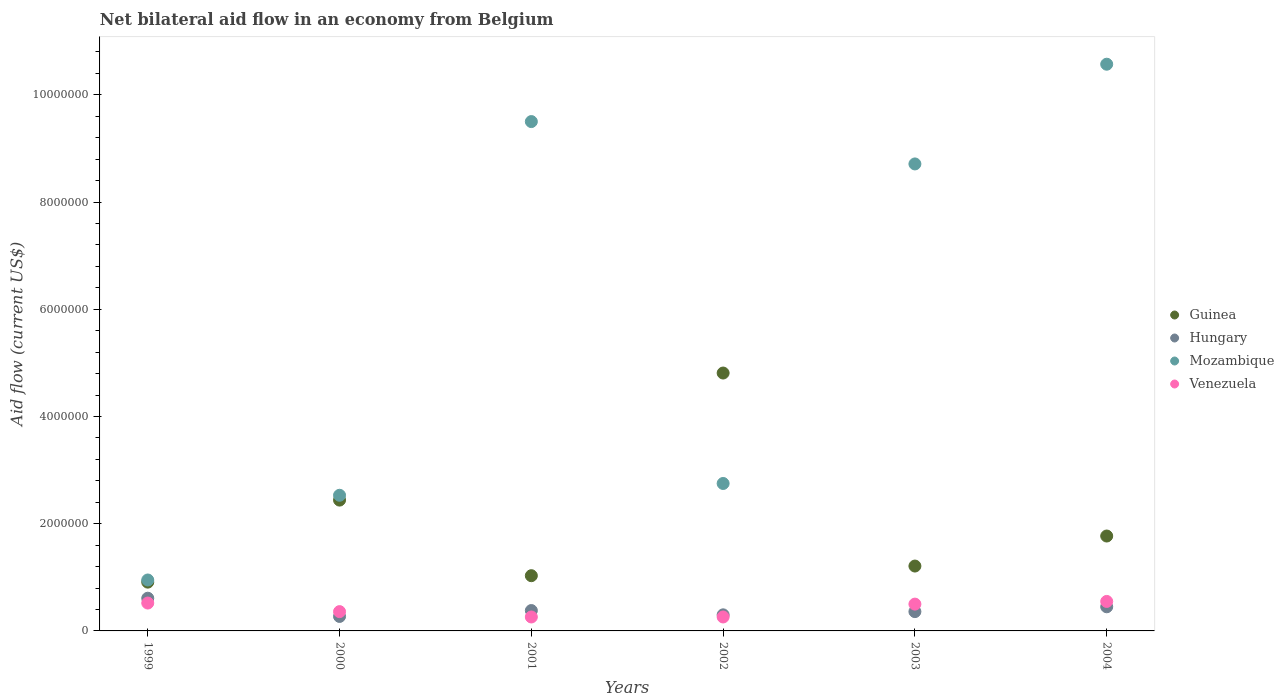How many different coloured dotlines are there?
Provide a short and direct response. 4. Is the number of dotlines equal to the number of legend labels?
Give a very brief answer. Yes. What is the net bilateral aid flow in Venezuela in 1999?
Keep it short and to the point. 5.20e+05. Across all years, what is the maximum net bilateral aid flow in Hungary?
Offer a very short reply. 6.10e+05. Across all years, what is the minimum net bilateral aid flow in Guinea?
Keep it short and to the point. 9.10e+05. What is the total net bilateral aid flow in Guinea in the graph?
Ensure brevity in your answer.  1.22e+07. What is the difference between the net bilateral aid flow in Hungary in 2004 and the net bilateral aid flow in Guinea in 2000?
Ensure brevity in your answer.  -1.99e+06. What is the average net bilateral aid flow in Guinea per year?
Your response must be concise. 2.03e+06. In the year 2001, what is the difference between the net bilateral aid flow in Venezuela and net bilateral aid flow in Hungary?
Your response must be concise. -1.20e+05. In how many years, is the net bilateral aid flow in Venezuela greater than 7600000 US$?
Provide a succinct answer. 0. What is the ratio of the net bilateral aid flow in Hungary in 2000 to that in 2003?
Provide a succinct answer. 0.75. What is the difference between the highest and the lowest net bilateral aid flow in Venezuela?
Give a very brief answer. 2.90e+05. Is it the case that in every year, the sum of the net bilateral aid flow in Hungary and net bilateral aid flow in Guinea  is greater than the sum of net bilateral aid flow in Venezuela and net bilateral aid flow in Mozambique?
Ensure brevity in your answer.  Yes. Is the net bilateral aid flow in Venezuela strictly greater than the net bilateral aid flow in Hungary over the years?
Give a very brief answer. No. How many dotlines are there?
Keep it short and to the point. 4. Are the values on the major ticks of Y-axis written in scientific E-notation?
Your answer should be very brief. No. Does the graph contain any zero values?
Offer a terse response. No. Does the graph contain grids?
Your answer should be very brief. No. How are the legend labels stacked?
Keep it short and to the point. Vertical. What is the title of the graph?
Provide a short and direct response. Net bilateral aid flow in an economy from Belgium. What is the label or title of the X-axis?
Give a very brief answer. Years. What is the label or title of the Y-axis?
Keep it short and to the point. Aid flow (current US$). What is the Aid flow (current US$) in Guinea in 1999?
Keep it short and to the point. 9.10e+05. What is the Aid flow (current US$) of Hungary in 1999?
Provide a short and direct response. 6.10e+05. What is the Aid flow (current US$) of Mozambique in 1999?
Ensure brevity in your answer.  9.50e+05. What is the Aid flow (current US$) of Venezuela in 1999?
Keep it short and to the point. 5.20e+05. What is the Aid flow (current US$) in Guinea in 2000?
Your answer should be very brief. 2.44e+06. What is the Aid flow (current US$) in Mozambique in 2000?
Give a very brief answer. 2.53e+06. What is the Aid flow (current US$) in Venezuela in 2000?
Offer a very short reply. 3.60e+05. What is the Aid flow (current US$) in Guinea in 2001?
Your response must be concise. 1.03e+06. What is the Aid flow (current US$) of Hungary in 2001?
Provide a succinct answer. 3.80e+05. What is the Aid flow (current US$) of Mozambique in 2001?
Provide a short and direct response. 9.50e+06. What is the Aid flow (current US$) of Venezuela in 2001?
Ensure brevity in your answer.  2.60e+05. What is the Aid flow (current US$) in Guinea in 2002?
Provide a succinct answer. 4.81e+06. What is the Aid flow (current US$) in Hungary in 2002?
Your response must be concise. 3.00e+05. What is the Aid flow (current US$) of Mozambique in 2002?
Your answer should be compact. 2.75e+06. What is the Aid flow (current US$) of Guinea in 2003?
Keep it short and to the point. 1.21e+06. What is the Aid flow (current US$) of Mozambique in 2003?
Give a very brief answer. 8.71e+06. What is the Aid flow (current US$) of Guinea in 2004?
Offer a terse response. 1.77e+06. What is the Aid flow (current US$) in Mozambique in 2004?
Give a very brief answer. 1.06e+07. What is the Aid flow (current US$) in Venezuela in 2004?
Offer a very short reply. 5.50e+05. Across all years, what is the maximum Aid flow (current US$) in Guinea?
Provide a succinct answer. 4.81e+06. Across all years, what is the maximum Aid flow (current US$) of Hungary?
Your response must be concise. 6.10e+05. Across all years, what is the maximum Aid flow (current US$) in Mozambique?
Keep it short and to the point. 1.06e+07. Across all years, what is the maximum Aid flow (current US$) in Venezuela?
Make the answer very short. 5.50e+05. Across all years, what is the minimum Aid flow (current US$) of Guinea?
Provide a succinct answer. 9.10e+05. Across all years, what is the minimum Aid flow (current US$) of Hungary?
Provide a succinct answer. 2.70e+05. Across all years, what is the minimum Aid flow (current US$) of Mozambique?
Keep it short and to the point. 9.50e+05. Across all years, what is the minimum Aid flow (current US$) in Venezuela?
Your response must be concise. 2.60e+05. What is the total Aid flow (current US$) in Guinea in the graph?
Make the answer very short. 1.22e+07. What is the total Aid flow (current US$) in Hungary in the graph?
Ensure brevity in your answer.  2.37e+06. What is the total Aid flow (current US$) of Mozambique in the graph?
Your answer should be compact. 3.50e+07. What is the total Aid flow (current US$) of Venezuela in the graph?
Provide a succinct answer. 2.45e+06. What is the difference between the Aid flow (current US$) in Guinea in 1999 and that in 2000?
Make the answer very short. -1.53e+06. What is the difference between the Aid flow (current US$) in Mozambique in 1999 and that in 2000?
Offer a terse response. -1.58e+06. What is the difference between the Aid flow (current US$) of Venezuela in 1999 and that in 2000?
Make the answer very short. 1.60e+05. What is the difference between the Aid flow (current US$) of Hungary in 1999 and that in 2001?
Provide a succinct answer. 2.30e+05. What is the difference between the Aid flow (current US$) in Mozambique in 1999 and that in 2001?
Your answer should be compact. -8.55e+06. What is the difference between the Aid flow (current US$) in Guinea in 1999 and that in 2002?
Offer a very short reply. -3.90e+06. What is the difference between the Aid flow (current US$) of Hungary in 1999 and that in 2002?
Ensure brevity in your answer.  3.10e+05. What is the difference between the Aid flow (current US$) in Mozambique in 1999 and that in 2002?
Provide a succinct answer. -1.80e+06. What is the difference between the Aid flow (current US$) of Venezuela in 1999 and that in 2002?
Your answer should be very brief. 2.60e+05. What is the difference between the Aid flow (current US$) of Guinea in 1999 and that in 2003?
Make the answer very short. -3.00e+05. What is the difference between the Aid flow (current US$) of Hungary in 1999 and that in 2003?
Offer a very short reply. 2.50e+05. What is the difference between the Aid flow (current US$) in Mozambique in 1999 and that in 2003?
Keep it short and to the point. -7.76e+06. What is the difference between the Aid flow (current US$) of Guinea in 1999 and that in 2004?
Keep it short and to the point. -8.60e+05. What is the difference between the Aid flow (current US$) of Mozambique in 1999 and that in 2004?
Give a very brief answer. -9.62e+06. What is the difference between the Aid flow (current US$) in Venezuela in 1999 and that in 2004?
Offer a terse response. -3.00e+04. What is the difference between the Aid flow (current US$) of Guinea in 2000 and that in 2001?
Your answer should be very brief. 1.41e+06. What is the difference between the Aid flow (current US$) of Mozambique in 2000 and that in 2001?
Offer a terse response. -6.97e+06. What is the difference between the Aid flow (current US$) in Venezuela in 2000 and that in 2001?
Provide a short and direct response. 1.00e+05. What is the difference between the Aid flow (current US$) of Guinea in 2000 and that in 2002?
Provide a succinct answer. -2.37e+06. What is the difference between the Aid flow (current US$) of Hungary in 2000 and that in 2002?
Provide a succinct answer. -3.00e+04. What is the difference between the Aid flow (current US$) of Mozambique in 2000 and that in 2002?
Provide a succinct answer. -2.20e+05. What is the difference between the Aid flow (current US$) in Venezuela in 2000 and that in 2002?
Ensure brevity in your answer.  1.00e+05. What is the difference between the Aid flow (current US$) of Guinea in 2000 and that in 2003?
Your answer should be very brief. 1.23e+06. What is the difference between the Aid flow (current US$) in Mozambique in 2000 and that in 2003?
Provide a succinct answer. -6.18e+06. What is the difference between the Aid flow (current US$) of Venezuela in 2000 and that in 2003?
Ensure brevity in your answer.  -1.40e+05. What is the difference between the Aid flow (current US$) in Guinea in 2000 and that in 2004?
Make the answer very short. 6.70e+05. What is the difference between the Aid flow (current US$) of Hungary in 2000 and that in 2004?
Provide a short and direct response. -1.80e+05. What is the difference between the Aid flow (current US$) in Mozambique in 2000 and that in 2004?
Ensure brevity in your answer.  -8.04e+06. What is the difference between the Aid flow (current US$) of Venezuela in 2000 and that in 2004?
Ensure brevity in your answer.  -1.90e+05. What is the difference between the Aid flow (current US$) of Guinea in 2001 and that in 2002?
Give a very brief answer. -3.78e+06. What is the difference between the Aid flow (current US$) in Mozambique in 2001 and that in 2002?
Offer a very short reply. 6.75e+06. What is the difference between the Aid flow (current US$) of Venezuela in 2001 and that in 2002?
Provide a succinct answer. 0. What is the difference between the Aid flow (current US$) in Guinea in 2001 and that in 2003?
Your answer should be compact. -1.80e+05. What is the difference between the Aid flow (current US$) in Mozambique in 2001 and that in 2003?
Provide a succinct answer. 7.90e+05. What is the difference between the Aid flow (current US$) of Venezuela in 2001 and that in 2003?
Your answer should be very brief. -2.40e+05. What is the difference between the Aid flow (current US$) of Guinea in 2001 and that in 2004?
Offer a very short reply. -7.40e+05. What is the difference between the Aid flow (current US$) in Mozambique in 2001 and that in 2004?
Your response must be concise. -1.07e+06. What is the difference between the Aid flow (current US$) of Guinea in 2002 and that in 2003?
Provide a succinct answer. 3.60e+06. What is the difference between the Aid flow (current US$) of Hungary in 2002 and that in 2003?
Make the answer very short. -6.00e+04. What is the difference between the Aid flow (current US$) of Mozambique in 2002 and that in 2003?
Your answer should be very brief. -5.96e+06. What is the difference between the Aid flow (current US$) of Guinea in 2002 and that in 2004?
Offer a terse response. 3.04e+06. What is the difference between the Aid flow (current US$) in Mozambique in 2002 and that in 2004?
Ensure brevity in your answer.  -7.82e+06. What is the difference between the Aid flow (current US$) in Guinea in 2003 and that in 2004?
Offer a very short reply. -5.60e+05. What is the difference between the Aid flow (current US$) of Mozambique in 2003 and that in 2004?
Offer a very short reply. -1.86e+06. What is the difference between the Aid flow (current US$) of Guinea in 1999 and the Aid flow (current US$) of Hungary in 2000?
Give a very brief answer. 6.40e+05. What is the difference between the Aid flow (current US$) in Guinea in 1999 and the Aid flow (current US$) in Mozambique in 2000?
Offer a terse response. -1.62e+06. What is the difference between the Aid flow (current US$) of Hungary in 1999 and the Aid flow (current US$) of Mozambique in 2000?
Keep it short and to the point. -1.92e+06. What is the difference between the Aid flow (current US$) of Hungary in 1999 and the Aid flow (current US$) of Venezuela in 2000?
Give a very brief answer. 2.50e+05. What is the difference between the Aid flow (current US$) of Mozambique in 1999 and the Aid flow (current US$) of Venezuela in 2000?
Give a very brief answer. 5.90e+05. What is the difference between the Aid flow (current US$) in Guinea in 1999 and the Aid flow (current US$) in Hungary in 2001?
Keep it short and to the point. 5.30e+05. What is the difference between the Aid flow (current US$) in Guinea in 1999 and the Aid flow (current US$) in Mozambique in 2001?
Your answer should be compact. -8.59e+06. What is the difference between the Aid flow (current US$) of Guinea in 1999 and the Aid flow (current US$) of Venezuela in 2001?
Offer a very short reply. 6.50e+05. What is the difference between the Aid flow (current US$) in Hungary in 1999 and the Aid flow (current US$) in Mozambique in 2001?
Your response must be concise. -8.89e+06. What is the difference between the Aid flow (current US$) in Mozambique in 1999 and the Aid flow (current US$) in Venezuela in 2001?
Your response must be concise. 6.90e+05. What is the difference between the Aid flow (current US$) of Guinea in 1999 and the Aid flow (current US$) of Mozambique in 2002?
Keep it short and to the point. -1.84e+06. What is the difference between the Aid flow (current US$) in Guinea in 1999 and the Aid flow (current US$) in Venezuela in 2002?
Your answer should be very brief. 6.50e+05. What is the difference between the Aid flow (current US$) in Hungary in 1999 and the Aid flow (current US$) in Mozambique in 2002?
Give a very brief answer. -2.14e+06. What is the difference between the Aid flow (current US$) in Mozambique in 1999 and the Aid flow (current US$) in Venezuela in 2002?
Provide a short and direct response. 6.90e+05. What is the difference between the Aid flow (current US$) of Guinea in 1999 and the Aid flow (current US$) of Hungary in 2003?
Your answer should be very brief. 5.50e+05. What is the difference between the Aid flow (current US$) of Guinea in 1999 and the Aid flow (current US$) of Mozambique in 2003?
Give a very brief answer. -7.80e+06. What is the difference between the Aid flow (current US$) in Hungary in 1999 and the Aid flow (current US$) in Mozambique in 2003?
Offer a terse response. -8.10e+06. What is the difference between the Aid flow (current US$) in Hungary in 1999 and the Aid flow (current US$) in Venezuela in 2003?
Make the answer very short. 1.10e+05. What is the difference between the Aid flow (current US$) in Mozambique in 1999 and the Aid flow (current US$) in Venezuela in 2003?
Give a very brief answer. 4.50e+05. What is the difference between the Aid flow (current US$) of Guinea in 1999 and the Aid flow (current US$) of Hungary in 2004?
Provide a succinct answer. 4.60e+05. What is the difference between the Aid flow (current US$) in Guinea in 1999 and the Aid flow (current US$) in Mozambique in 2004?
Offer a terse response. -9.66e+06. What is the difference between the Aid flow (current US$) in Guinea in 1999 and the Aid flow (current US$) in Venezuela in 2004?
Keep it short and to the point. 3.60e+05. What is the difference between the Aid flow (current US$) in Hungary in 1999 and the Aid flow (current US$) in Mozambique in 2004?
Give a very brief answer. -9.96e+06. What is the difference between the Aid flow (current US$) of Hungary in 1999 and the Aid flow (current US$) of Venezuela in 2004?
Give a very brief answer. 6.00e+04. What is the difference between the Aid flow (current US$) in Guinea in 2000 and the Aid flow (current US$) in Hungary in 2001?
Keep it short and to the point. 2.06e+06. What is the difference between the Aid flow (current US$) in Guinea in 2000 and the Aid flow (current US$) in Mozambique in 2001?
Your answer should be compact. -7.06e+06. What is the difference between the Aid flow (current US$) of Guinea in 2000 and the Aid flow (current US$) of Venezuela in 2001?
Provide a short and direct response. 2.18e+06. What is the difference between the Aid flow (current US$) of Hungary in 2000 and the Aid flow (current US$) of Mozambique in 2001?
Your answer should be very brief. -9.23e+06. What is the difference between the Aid flow (current US$) in Mozambique in 2000 and the Aid flow (current US$) in Venezuela in 2001?
Your response must be concise. 2.27e+06. What is the difference between the Aid flow (current US$) in Guinea in 2000 and the Aid flow (current US$) in Hungary in 2002?
Ensure brevity in your answer.  2.14e+06. What is the difference between the Aid flow (current US$) of Guinea in 2000 and the Aid flow (current US$) of Mozambique in 2002?
Ensure brevity in your answer.  -3.10e+05. What is the difference between the Aid flow (current US$) of Guinea in 2000 and the Aid flow (current US$) of Venezuela in 2002?
Your answer should be very brief. 2.18e+06. What is the difference between the Aid flow (current US$) of Hungary in 2000 and the Aid flow (current US$) of Mozambique in 2002?
Keep it short and to the point. -2.48e+06. What is the difference between the Aid flow (current US$) of Mozambique in 2000 and the Aid flow (current US$) of Venezuela in 2002?
Offer a very short reply. 2.27e+06. What is the difference between the Aid flow (current US$) of Guinea in 2000 and the Aid flow (current US$) of Hungary in 2003?
Provide a succinct answer. 2.08e+06. What is the difference between the Aid flow (current US$) of Guinea in 2000 and the Aid flow (current US$) of Mozambique in 2003?
Ensure brevity in your answer.  -6.27e+06. What is the difference between the Aid flow (current US$) in Guinea in 2000 and the Aid flow (current US$) in Venezuela in 2003?
Provide a succinct answer. 1.94e+06. What is the difference between the Aid flow (current US$) in Hungary in 2000 and the Aid flow (current US$) in Mozambique in 2003?
Give a very brief answer. -8.44e+06. What is the difference between the Aid flow (current US$) of Mozambique in 2000 and the Aid flow (current US$) of Venezuela in 2003?
Your answer should be compact. 2.03e+06. What is the difference between the Aid flow (current US$) in Guinea in 2000 and the Aid flow (current US$) in Hungary in 2004?
Provide a succinct answer. 1.99e+06. What is the difference between the Aid flow (current US$) of Guinea in 2000 and the Aid flow (current US$) of Mozambique in 2004?
Provide a short and direct response. -8.13e+06. What is the difference between the Aid flow (current US$) in Guinea in 2000 and the Aid flow (current US$) in Venezuela in 2004?
Make the answer very short. 1.89e+06. What is the difference between the Aid flow (current US$) in Hungary in 2000 and the Aid flow (current US$) in Mozambique in 2004?
Offer a terse response. -1.03e+07. What is the difference between the Aid flow (current US$) in Hungary in 2000 and the Aid flow (current US$) in Venezuela in 2004?
Give a very brief answer. -2.80e+05. What is the difference between the Aid flow (current US$) of Mozambique in 2000 and the Aid flow (current US$) of Venezuela in 2004?
Make the answer very short. 1.98e+06. What is the difference between the Aid flow (current US$) of Guinea in 2001 and the Aid flow (current US$) of Hungary in 2002?
Ensure brevity in your answer.  7.30e+05. What is the difference between the Aid flow (current US$) in Guinea in 2001 and the Aid flow (current US$) in Mozambique in 2002?
Offer a very short reply. -1.72e+06. What is the difference between the Aid flow (current US$) in Guinea in 2001 and the Aid flow (current US$) in Venezuela in 2002?
Ensure brevity in your answer.  7.70e+05. What is the difference between the Aid flow (current US$) in Hungary in 2001 and the Aid flow (current US$) in Mozambique in 2002?
Your answer should be very brief. -2.37e+06. What is the difference between the Aid flow (current US$) of Hungary in 2001 and the Aid flow (current US$) of Venezuela in 2002?
Make the answer very short. 1.20e+05. What is the difference between the Aid flow (current US$) of Mozambique in 2001 and the Aid flow (current US$) of Venezuela in 2002?
Make the answer very short. 9.24e+06. What is the difference between the Aid flow (current US$) in Guinea in 2001 and the Aid flow (current US$) in Hungary in 2003?
Give a very brief answer. 6.70e+05. What is the difference between the Aid flow (current US$) of Guinea in 2001 and the Aid flow (current US$) of Mozambique in 2003?
Your answer should be very brief. -7.68e+06. What is the difference between the Aid flow (current US$) in Guinea in 2001 and the Aid flow (current US$) in Venezuela in 2003?
Keep it short and to the point. 5.30e+05. What is the difference between the Aid flow (current US$) of Hungary in 2001 and the Aid flow (current US$) of Mozambique in 2003?
Provide a succinct answer. -8.33e+06. What is the difference between the Aid flow (current US$) of Mozambique in 2001 and the Aid flow (current US$) of Venezuela in 2003?
Ensure brevity in your answer.  9.00e+06. What is the difference between the Aid flow (current US$) of Guinea in 2001 and the Aid flow (current US$) of Hungary in 2004?
Provide a succinct answer. 5.80e+05. What is the difference between the Aid flow (current US$) in Guinea in 2001 and the Aid flow (current US$) in Mozambique in 2004?
Ensure brevity in your answer.  -9.54e+06. What is the difference between the Aid flow (current US$) in Guinea in 2001 and the Aid flow (current US$) in Venezuela in 2004?
Provide a short and direct response. 4.80e+05. What is the difference between the Aid flow (current US$) of Hungary in 2001 and the Aid flow (current US$) of Mozambique in 2004?
Make the answer very short. -1.02e+07. What is the difference between the Aid flow (current US$) of Mozambique in 2001 and the Aid flow (current US$) of Venezuela in 2004?
Provide a short and direct response. 8.95e+06. What is the difference between the Aid flow (current US$) in Guinea in 2002 and the Aid flow (current US$) in Hungary in 2003?
Your response must be concise. 4.45e+06. What is the difference between the Aid flow (current US$) of Guinea in 2002 and the Aid flow (current US$) of Mozambique in 2003?
Provide a short and direct response. -3.90e+06. What is the difference between the Aid flow (current US$) in Guinea in 2002 and the Aid flow (current US$) in Venezuela in 2003?
Your answer should be very brief. 4.31e+06. What is the difference between the Aid flow (current US$) of Hungary in 2002 and the Aid flow (current US$) of Mozambique in 2003?
Make the answer very short. -8.41e+06. What is the difference between the Aid flow (current US$) of Hungary in 2002 and the Aid flow (current US$) of Venezuela in 2003?
Your answer should be very brief. -2.00e+05. What is the difference between the Aid flow (current US$) of Mozambique in 2002 and the Aid flow (current US$) of Venezuela in 2003?
Provide a short and direct response. 2.25e+06. What is the difference between the Aid flow (current US$) in Guinea in 2002 and the Aid flow (current US$) in Hungary in 2004?
Offer a very short reply. 4.36e+06. What is the difference between the Aid flow (current US$) in Guinea in 2002 and the Aid flow (current US$) in Mozambique in 2004?
Provide a succinct answer. -5.76e+06. What is the difference between the Aid flow (current US$) in Guinea in 2002 and the Aid flow (current US$) in Venezuela in 2004?
Your answer should be compact. 4.26e+06. What is the difference between the Aid flow (current US$) in Hungary in 2002 and the Aid flow (current US$) in Mozambique in 2004?
Ensure brevity in your answer.  -1.03e+07. What is the difference between the Aid flow (current US$) of Hungary in 2002 and the Aid flow (current US$) of Venezuela in 2004?
Your answer should be very brief. -2.50e+05. What is the difference between the Aid flow (current US$) in Mozambique in 2002 and the Aid flow (current US$) in Venezuela in 2004?
Offer a terse response. 2.20e+06. What is the difference between the Aid flow (current US$) of Guinea in 2003 and the Aid flow (current US$) of Hungary in 2004?
Give a very brief answer. 7.60e+05. What is the difference between the Aid flow (current US$) in Guinea in 2003 and the Aid flow (current US$) in Mozambique in 2004?
Keep it short and to the point. -9.36e+06. What is the difference between the Aid flow (current US$) of Guinea in 2003 and the Aid flow (current US$) of Venezuela in 2004?
Ensure brevity in your answer.  6.60e+05. What is the difference between the Aid flow (current US$) of Hungary in 2003 and the Aid flow (current US$) of Mozambique in 2004?
Your answer should be very brief. -1.02e+07. What is the difference between the Aid flow (current US$) of Hungary in 2003 and the Aid flow (current US$) of Venezuela in 2004?
Your response must be concise. -1.90e+05. What is the difference between the Aid flow (current US$) of Mozambique in 2003 and the Aid flow (current US$) of Venezuela in 2004?
Your response must be concise. 8.16e+06. What is the average Aid flow (current US$) of Guinea per year?
Provide a short and direct response. 2.03e+06. What is the average Aid flow (current US$) of Hungary per year?
Ensure brevity in your answer.  3.95e+05. What is the average Aid flow (current US$) of Mozambique per year?
Provide a short and direct response. 5.84e+06. What is the average Aid flow (current US$) in Venezuela per year?
Ensure brevity in your answer.  4.08e+05. In the year 1999, what is the difference between the Aid flow (current US$) in Guinea and Aid flow (current US$) in Mozambique?
Provide a short and direct response. -4.00e+04. In the year 1999, what is the difference between the Aid flow (current US$) in Hungary and Aid flow (current US$) in Mozambique?
Make the answer very short. -3.40e+05. In the year 2000, what is the difference between the Aid flow (current US$) in Guinea and Aid flow (current US$) in Hungary?
Offer a very short reply. 2.17e+06. In the year 2000, what is the difference between the Aid flow (current US$) of Guinea and Aid flow (current US$) of Venezuela?
Keep it short and to the point. 2.08e+06. In the year 2000, what is the difference between the Aid flow (current US$) of Hungary and Aid flow (current US$) of Mozambique?
Provide a short and direct response. -2.26e+06. In the year 2000, what is the difference between the Aid flow (current US$) in Hungary and Aid flow (current US$) in Venezuela?
Provide a succinct answer. -9.00e+04. In the year 2000, what is the difference between the Aid flow (current US$) of Mozambique and Aid flow (current US$) of Venezuela?
Offer a very short reply. 2.17e+06. In the year 2001, what is the difference between the Aid flow (current US$) in Guinea and Aid flow (current US$) in Hungary?
Provide a succinct answer. 6.50e+05. In the year 2001, what is the difference between the Aid flow (current US$) in Guinea and Aid flow (current US$) in Mozambique?
Keep it short and to the point. -8.47e+06. In the year 2001, what is the difference between the Aid flow (current US$) in Guinea and Aid flow (current US$) in Venezuela?
Provide a succinct answer. 7.70e+05. In the year 2001, what is the difference between the Aid flow (current US$) in Hungary and Aid flow (current US$) in Mozambique?
Your response must be concise. -9.12e+06. In the year 2001, what is the difference between the Aid flow (current US$) of Hungary and Aid flow (current US$) of Venezuela?
Provide a short and direct response. 1.20e+05. In the year 2001, what is the difference between the Aid flow (current US$) of Mozambique and Aid flow (current US$) of Venezuela?
Provide a succinct answer. 9.24e+06. In the year 2002, what is the difference between the Aid flow (current US$) in Guinea and Aid flow (current US$) in Hungary?
Offer a terse response. 4.51e+06. In the year 2002, what is the difference between the Aid flow (current US$) in Guinea and Aid flow (current US$) in Mozambique?
Offer a very short reply. 2.06e+06. In the year 2002, what is the difference between the Aid flow (current US$) of Guinea and Aid flow (current US$) of Venezuela?
Ensure brevity in your answer.  4.55e+06. In the year 2002, what is the difference between the Aid flow (current US$) of Hungary and Aid flow (current US$) of Mozambique?
Your response must be concise. -2.45e+06. In the year 2002, what is the difference between the Aid flow (current US$) in Mozambique and Aid flow (current US$) in Venezuela?
Give a very brief answer. 2.49e+06. In the year 2003, what is the difference between the Aid flow (current US$) of Guinea and Aid flow (current US$) of Hungary?
Provide a succinct answer. 8.50e+05. In the year 2003, what is the difference between the Aid flow (current US$) in Guinea and Aid flow (current US$) in Mozambique?
Your answer should be compact. -7.50e+06. In the year 2003, what is the difference between the Aid flow (current US$) of Guinea and Aid flow (current US$) of Venezuela?
Provide a succinct answer. 7.10e+05. In the year 2003, what is the difference between the Aid flow (current US$) of Hungary and Aid flow (current US$) of Mozambique?
Make the answer very short. -8.35e+06. In the year 2003, what is the difference between the Aid flow (current US$) in Hungary and Aid flow (current US$) in Venezuela?
Offer a terse response. -1.40e+05. In the year 2003, what is the difference between the Aid flow (current US$) of Mozambique and Aid flow (current US$) of Venezuela?
Provide a succinct answer. 8.21e+06. In the year 2004, what is the difference between the Aid flow (current US$) in Guinea and Aid flow (current US$) in Hungary?
Keep it short and to the point. 1.32e+06. In the year 2004, what is the difference between the Aid flow (current US$) in Guinea and Aid flow (current US$) in Mozambique?
Your answer should be compact. -8.80e+06. In the year 2004, what is the difference between the Aid flow (current US$) in Guinea and Aid flow (current US$) in Venezuela?
Your answer should be compact. 1.22e+06. In the year 2004, what is the difference between the Aid flow (current US$) in Hungary and Aid flow (current US$) in Mozambique?
Offer a terse response. -1.01e+07. In the year 2004, what is the difference between the Aid flow (current US$) of Mozambique and Aid flow (current US$) of Venezuela?
Ensure brevity in your answer.  1.00e+07. What is the ratio of the Aid flow (current US$) of Guinea in 1999 to that in 2000?
Your answer should be very brief. 0.37. What is the ratio of the Aid flow (current US$) in Hungary in 1999 to that in 2000?
Your response must be concise. 2.26. What is the ratio of the Aid flow (current US$) in Mozambique in 1999 to that in 2000?
Give a very brief answer. 0.38. What is the ratio of the Aid flow (current US$) of Venezuela in 1999 to that in 2000?
Your answer should be very brief. 1.44. What is the ratio of the Aid flow (current US$) of Guinea in 1999 to that in 2001?
Give a very brief answer. 0.88. What is the ratio of the Aid flow (current US$) in Hungary in 1999 to that in 2001?
Provide a succinct answer. 1.61. What is the ratio of the Aid flow (current US$) of Venezuela in 1999 to that in 2001?
Ensure brevity in your answer.  2. What is the ratio of the Aid flow (current US$) of Guinea in 1999 to that in 2002?
Give a very brief answer. 0.19. What is the ratio of the Aid flow (current US$) in Hungary in 1999 to that in 2002?
Keep it short and to the point. 2.03. What is the ratio of the Aid flow (current US$) in Mozambique in 1999 to that in 2002?
Your answer should be compact. 0.35. What is the ratio of the Aid flow (current US$) of Guinea in 1999 to that in 2003?
Ensure brevity in your answer.  0.75. What is the ratio of the Aid flow (current US$) in Hungary in 1999 to that in 2003?
Offer a terse response. 1.69. What is the ratio of the Aid flow (current US$) in Mozambique in 1999 to that in 2003?
Provide a succinct answer. 0.11. What is the ratio of the Aid flow (current US$) of Guinea in 1999 to that in 2004?
Provide a short and direct response. 0.51. What is the ratio of the Aid flow (current US$) in Hungary in 1999 to that in 2004?
Provide a short and direct response. 1.36. What is the ratio of the Aid flow (current US$) in Mozambique in 1999 to that in 2004?
Keep it short and to the point. 0.09. What is the ratio of the Aid flow (current US$) of Venezuela in 1999 to that in 2004?
Keep it short and to the point. 0.95. What is the ratio of the Aid flow (current US$) in Guinea in 2000 to that in 2001?
Give a very brief answer. 2.37. What is the ratio of the Aid flow (current US$) of Hungary in 2000 to that in 2001?
Your answer should be very brief. 0.71. What is the ratio of the Aid flow (current US$) of Mozambique in 2000 to that in 2001?
Keep it short and to the point. 0.27. What is the ratio of the Aid flow (current US$) in Venezuela in 2000 to that in 2001?
Your answer should be very brief. 1.38. What is the ratio of the Aid flow (current US$) in Guinea in 2000 to that in 2002?
Make the answer very short. 0.51. What is the ratio of the Aid flow (current US$) in Venezuela in 2000 to that in 2002?
Your response must be concise. 1.38. What is the ratio of the Aid flow (current US$) of Guinea in 2000 to that in 2003?
Ensure brevity in your answer.  2.02. What is the ratio of the Aid flow (current US$) of Mozambique in 2000 to that in 2003?
Give a very brief answer. 0.29. What is the ratio of the Aid flow (current US$) of Venezuela in 2000 to that in 2003?
Your response must be concise. 0.72. What is the ratio of the Aid flow (current US$) in Guinea in 2000 to that in 2004?
Your response must be concise. 1.38. What is the ratio of the Aid flow (current US$) in Hungary in 2000 to that in 2004?
Give a very brief answer. 0.6. What is the ratio of the Aid flow (current US$) in Mozambique in 2000 to that in 2004?
Provide a succinct answer. 0.24. What is the ratio of the Aid flow (current US$) of Venezuela in 2000 to that in 2004?
Keep it short and to the point. 0.65. What is the ratio of the Aid flow (current US$) in Guinea in 2001 to that in 2002?
Make the answer very short. 0.21. What is the ratio of the Aid flow (current US$) of Hungary in 2001 to that in 2002?
Your answer should be compact. 1.27. What is the ratio of the Aid flow (current US$) of Mozambique in 2001 to that in 2002?
Provide a short and direct response. 3.45. What is the ratio of the Aid flow (current US$) of Guinea in 2001 to that in 2003?
Keep it short and to the point. 0.85. What is the ratio of the Aid flow (current US$) of Hungary in 2001 to that in 2003?
Keep it short and to the point. 1.06. What is the ratio of the Aid flow (current US$) in Mozambique in 2001 to that in 2003?
Offer a terse response. 1.09. What is the ratio of the Aid flow (current US$) in Venezuela in 2001 to that in 2003?
Your answer should be very brief. 0.52. What is the ratio of the Aid flow (current US$) in Guinea in 2001 to that in 2004?
Keep it short and to the point. 0.58. What is the ratio of the Aid flow (current US$) in Hungary in 2001 to that in 2004?
Ensure brevity in your answer.  0.84. What is the ratio of the Aid flow (current US$) in Mozambique in 2001 to that in 2004?
Your answer should be very brief. 0.9. What is the ratio of the Aid flow (current US$) in Venezuela in 2001 to that in 2004?
Provide a succinct answer. 0.47. What is the ratio of the Aid flow (current US$) of Guinea in 2002 to that in 2003?
Ensure brevity in your answer.  3.98. What is the ratio of the Aid flow (current US$) of Mozambique in 2002 to that in 2003?
Offer a terse response. 0.32. What is the ratio of the Aid flow (current US$) of Venezuela in 2002 to that in 2003?
Give a very brief answer. 0.52. What is the ratio of the Aid flow (current US$) in Guinea in 2002 to that in 2004?
Keep it short and to the point. 2.72. What is the ratio of the Aid flow (current US$) of Mozambique in 2002 to that in 2004?
Keep it short and to the point. 0.26. What is the ratio of the Aid flow (current US$) of Venezuela in 2002 to that in 2004?
Keep it short and to the point. 0.47. What is the ratio of the Aid flow (current US$) of Guinea in 2003 to that in 2004?
Your answer should be very brief. 0.68. What is the ratio of the Aid flow (current US$) in Mozambique in 2003 to that in 2004?
Ensure brevity in your answer.  0.82. What is the ratio of the Aid flow (current US$) in Venezuela in 2003 to that in 2004?
Provide a succinct answer. 0.91. What is the difference between the highest and the second highest Aid flow (current US$) in Guinea?
Keep it short and to the point. 2.37e+06. What is the difference between the highest and the second highest Aid flow (current US$) in Mozambique?
Keep it short and to the point. 1.07e+06. What is the difference between the highest and the second highest Aid flow (current US$) of Venezuela?
Offer a terse response. 3.00e+04. What is the difference between the highest and the lowest Aid flow (current US$) in Guinea?
Keep it short and to the point. 3.90e+06. What is the difference between the highest and the lowest Aid flow (current US$) in Mozambique?
Keep it short and to the point. 9.62e+06. 